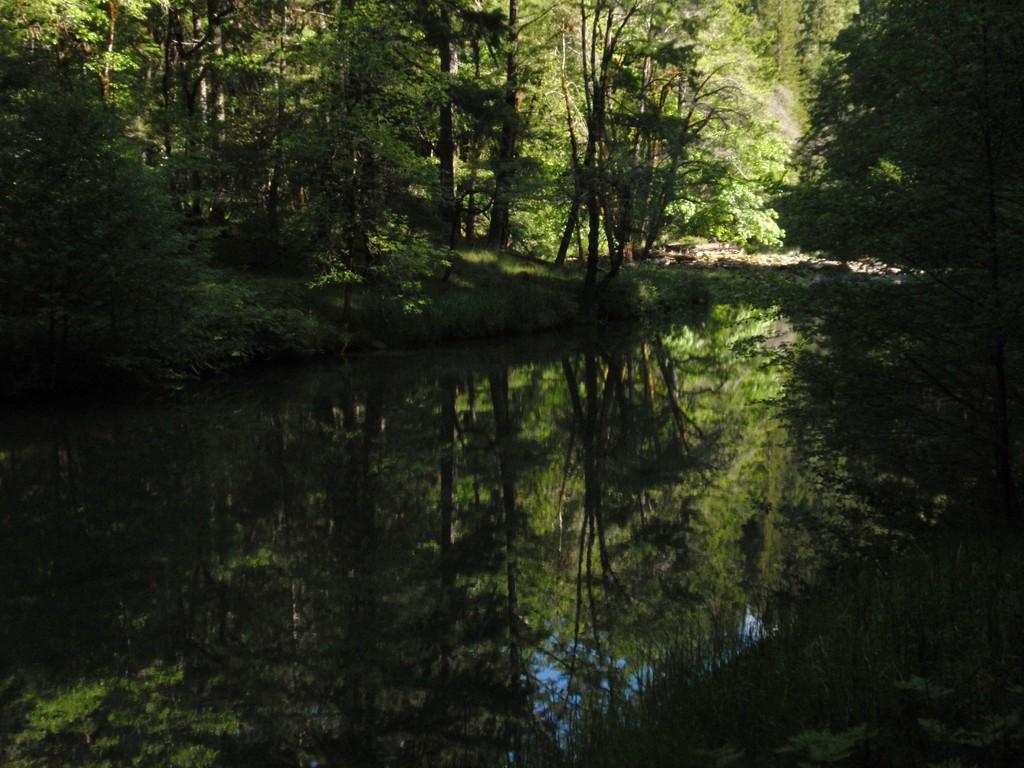What type of vegetation can be seen in the image? There are trees and plants in the image. What body of water is present in the image? There is a pond in the image. How is the area illuminated in the image? The area is covered with sunlight. What type of stitch is used to create the pond in the image? There is no stitching involved in creating the pond in the image; it is a natural body of water. What type of business is being conducted in the image? There is no business activity depicted in the image, nor is there any canvas present. 